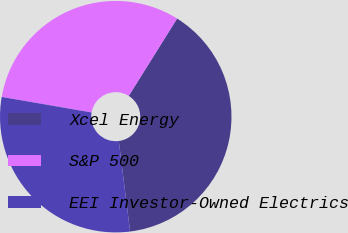Convert chart to OTSL. <chart><loc_0><loc_0><loc_500><loc_500><pie_chart><fcel>Xcel Energy<fcel>S&P 500<fcel>EEI Investor-Owned Electrics<nl><fcel>39.13%<fcel>31.16%<fcel>29.71%<nl></chart> 